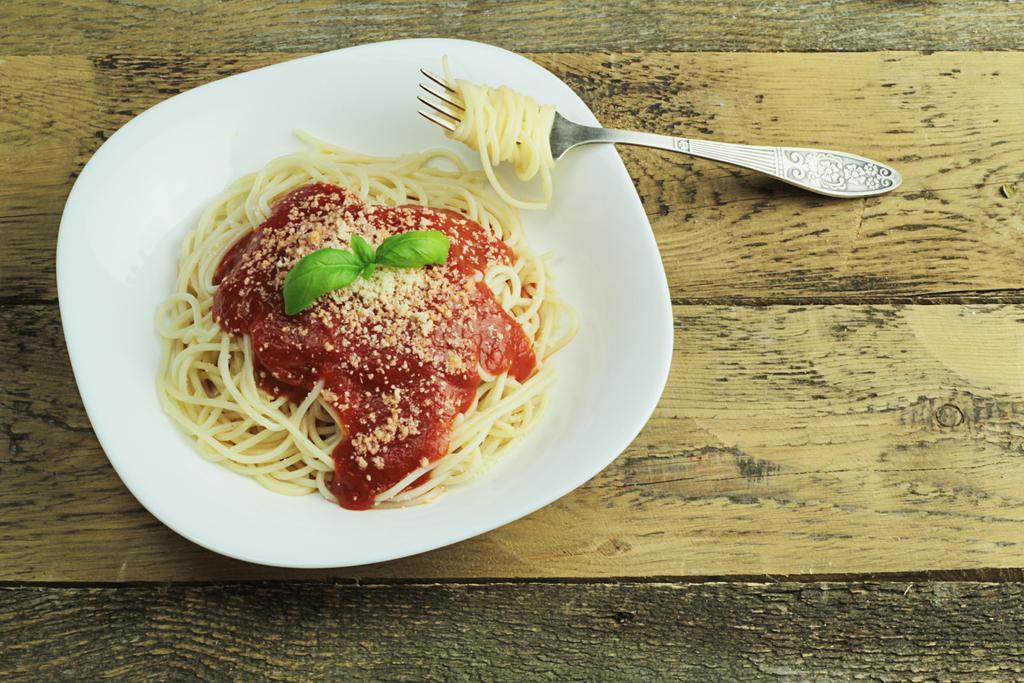In one or two sentences, can you explain what this image depicts? In the image there is a bowl of noodles with sauce and mint leaves over it along with a fork on a wooden table. 